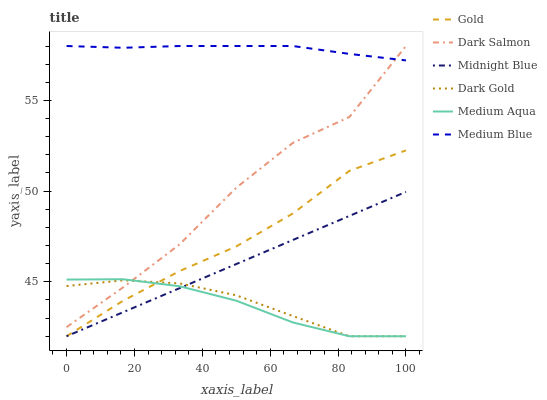Does Medium Aqua have the minimum area under the curve?
Answer yes or no. Yes. Does Medium Blue have the maximum area under the curve?
Answer yes or no. Yes. Does Gold have the minimum area under the curve?
Answer yes or no. No. Does Gold have the maximum area under the curve?
Answer yes or no. No. Is Midnight Blue the smoothest?
Answer yes or no. Yes. Is Dark Salmon the roughest?
Answer yes or no. Yes. Is Gold the smoothest?
Answer yes or no. No. Is Gold the roughest?
Answer yes or no. No. Does Midnight Blue have the lowest value?
Answer yes or no. Yes. Does Medium Blue have the lowest value?
Answer yes or no. No. Does Dark Salmon have the highest value?
Answer yes or no. Yes. Does Gold have the highest value?
Answer yes or no. No. Is Gold less than Dark Salmon?
Answer yes or no. Yes. Is Medium Blue greater than Midnight Blue?
Answer yes or no. Yes. Does Gold intersect Medium Aqua?
Answer yes or no. Yes. Is Gold less than Medium Aqua?
Answer yes or no. No. Is Gold greater than Medium Aqua?
Answer yes or no. No. Does Gold intersect Dark Salmon?
Answer yes or no. No. 